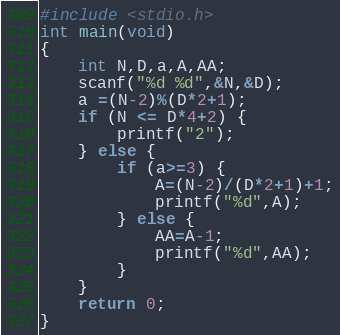<code> <loc_0><loc_0><loc_500><loc_500><_C_>#include <stdio.h>
int main(void)
{
	int N,D,a,A,AA;
	scanf("%d %d",&N,&D);
	a =(N-2)%(D*2+1);
	if (N <= D*4+2) {
		printf("2");
	} else {
		if (a>=3) {
			A=(N-2)/(D*2+1)+1;
			printf("%d",A);
		} else {
			AA=A-1;
			printf("%d",AA);
		}
	}
	return 0;
}</code> 